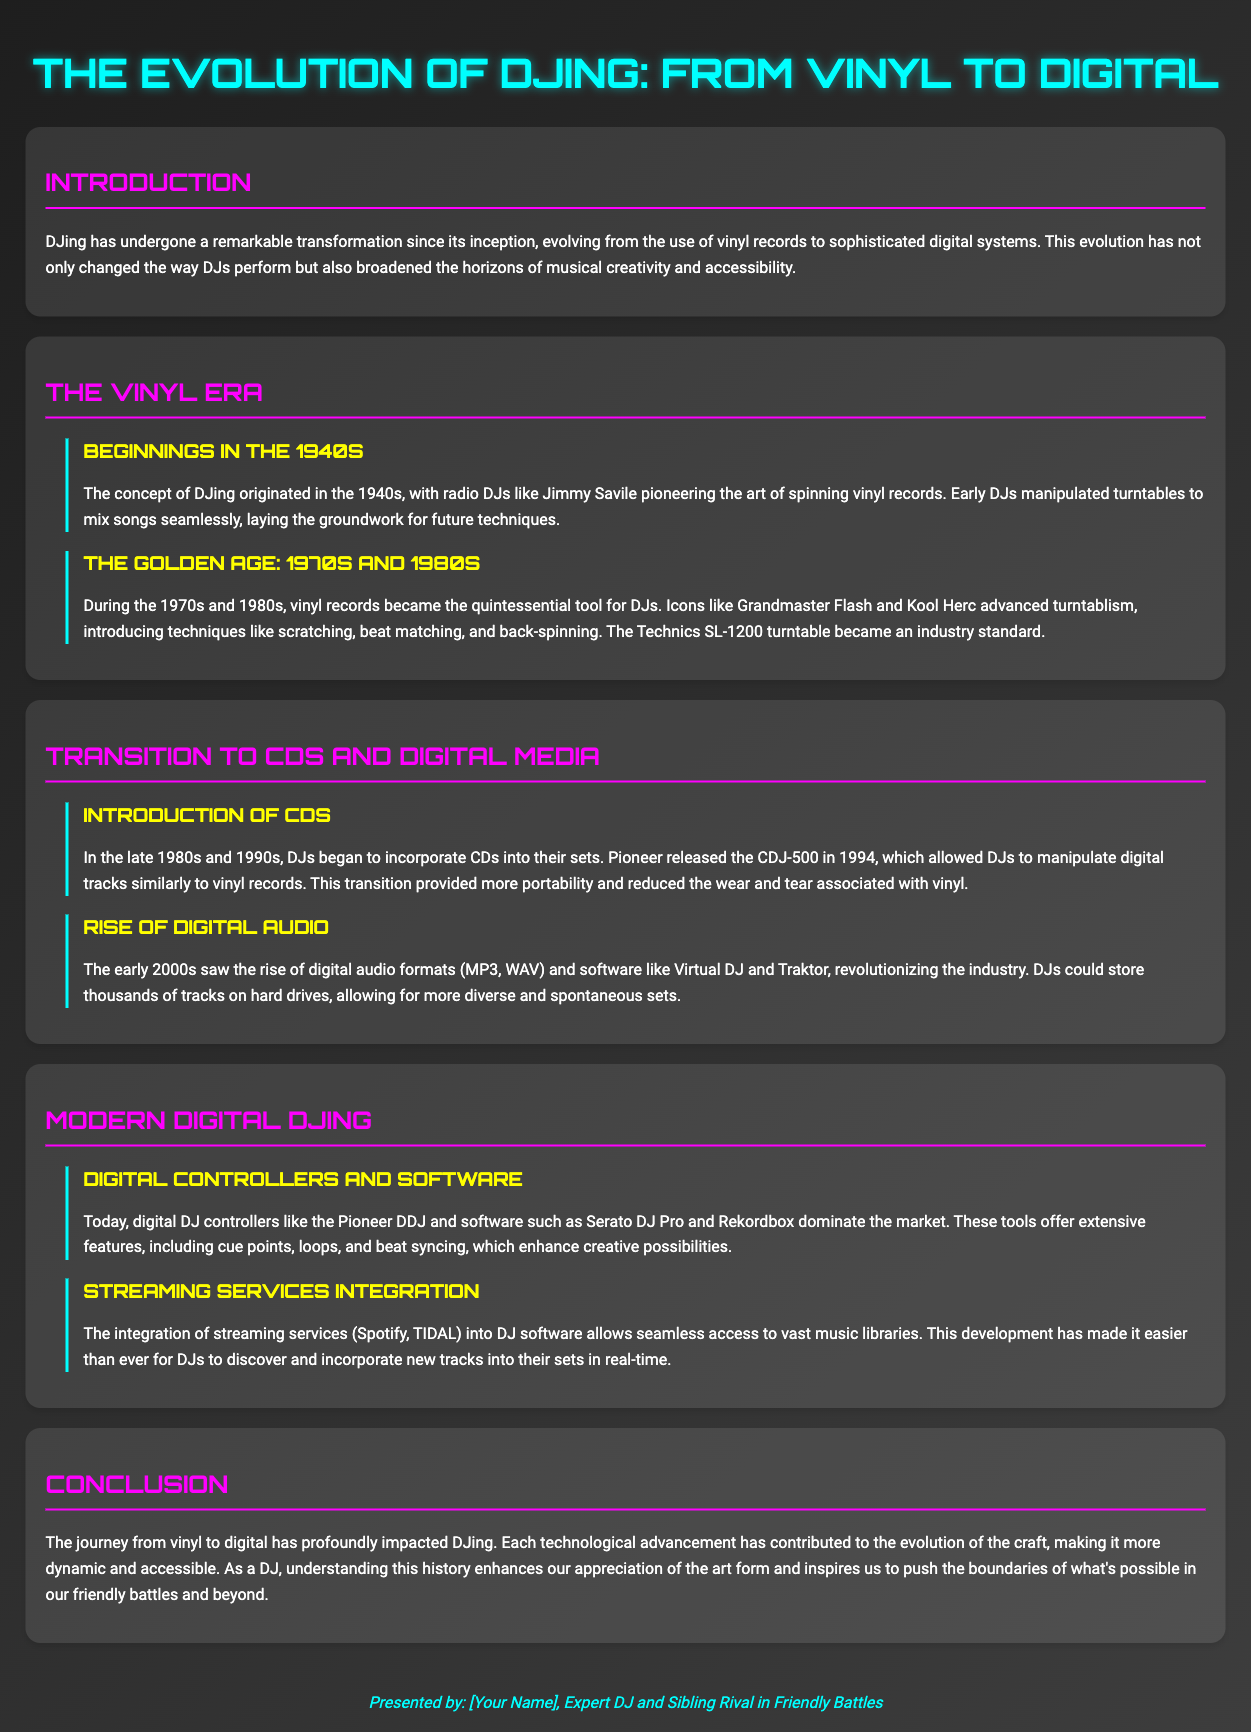What decade marked the beginnings of DJing? The document states that the concept of DJing originated in the 1940s.
Answer: 1940s Who pioneered the art of spinning vinyl records? Jimmy Savile is mentioned as a pioneering radio DJ in the document.
Answer: Jimmy Savile What turntable became an industry standard during the 1970s and 1980s? The text identifies the Technics SL-1200 turntable as the industry standard.
Answer: Technics SL-1200 Which CD player was released in 1994? The document refers to the Pioneer CDJ-500 as being released in 1994.
Answer: Pioneer CDJ-500 What software revolutionized DJing in the early 2000s? Virtual DJ and Traktor are mentioned as software that revolutionized the industry.
Answer: Virtual DJ and Traktor What main feature do modern digital controllers like the Pioneer DDJ offer? The document mentions extensive features including cue points, loops, and beat syncing.
Answer: Cue points, loops, and beat syncing Which streaming services are integrated into DJ software today? Spotify and TIDAL are highlighted as popular streaming services integrated into DJ software.
Answer: Spotify and TIDAL What two decades significantly contributed to the 'Golden Age' of DJing? The 1970s and 1980s are referred to as the decades of the Golden Age.
Answer: 1970s and 1980s How has the evolution from vinyl to digital impacted DJing? The evolution has made DJing more dynamic and accessible, according to the conclusion.
Answer: More dynamic and accessible 